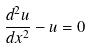Convert formula to latex. <formula><loc_0><loc_0><loc_500><loc_500>\frac { d ^ { 2 } u } { d x ^ { 2 } } - u = 0</formula> 